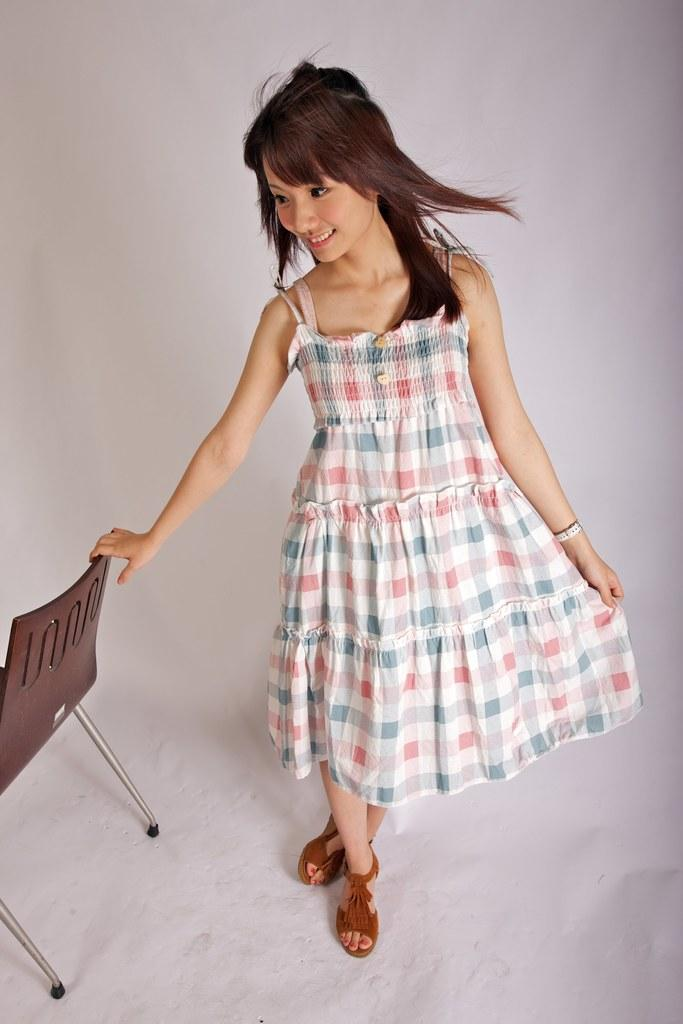Who is the main subject in the image? There is a woman in the image. What is the woman wearing? The woman is wearing light-colored clothes. What is the woman's facial expression? The woman is smiling. What is the woman doing in the image? The woman is catching a chair. What type of destruction can be seen in the image? There is no destruction present in the image. What route is the robin taking in the image? There is no robin present in the image. 